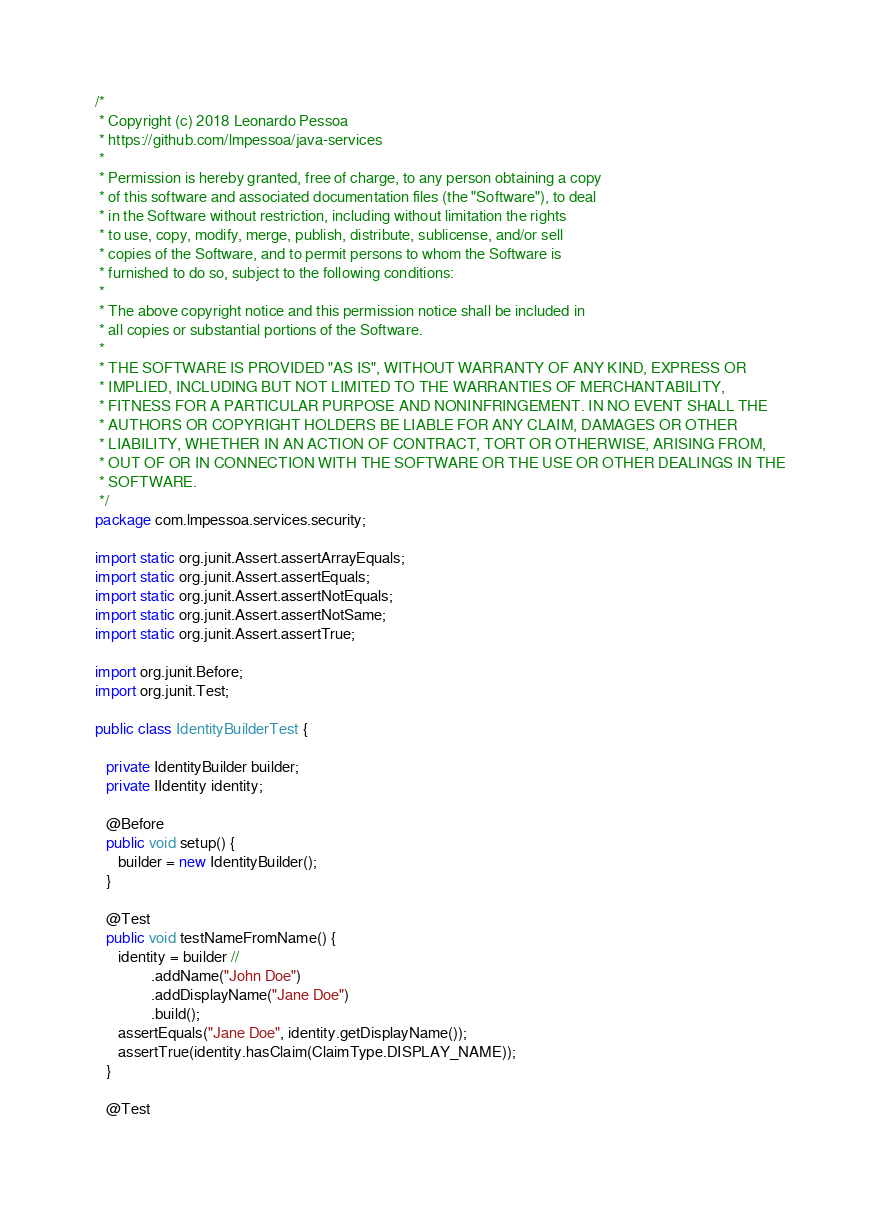<code> <loc_0><loc_0><loc_500><loc_500><_Java_>/*
 * Copyright (c) 2018 Leonardo Pessoa
 * https://github.com/lmpessoa/java-services
 *
 * Permission is hereby granted, free of charge, to any person obtaining a copy
 * of this software and associated documentation files (the "Software"), to deal
 * in the Software without restriction, including without limitation the rights
 * to use, copy, modify, merge, publish, distribute, sublicense, and/or sell
 * copies of the Software, and to permit persons to whom the Software is
 * furnished to do so, subject to the following conditions:
 *
 * The above copyright notice and this permission notice shall be included in
 * all copies or substantial portions of the Software.
 *
 * THE SOFTWARE IS PROVIDED "AS IS", WITHOUT WARRANTY OF ANY KIND, EXPRESS OR
 * IMPLIED, INCLUDING BUT NOT LIMITED TO THE WARRANTIES OF MERCHANTABILITY,
 * FITNESS FOR A PARTICULAR PURPOSE AND NONINFRINGEMENT. IN NO EVENT SHALL THE
 * AUTHORS OR COPYRIGHT HOLDERS BE LIABLE FOR ANY CLAIM, DAMAGES OR OTHER
 * LIABILITY, WHETHER IN AN ACTION OF CONTRACT, TORT OR OTHERWISE, ARISING FROM,
 * OUT OF OR IN CONNECTION WITH THE SOFTWARE OR THE USE OR OTHER DEALINGS IN THE
 * SOFTWARE.
 */
package com.lmpessoa.services.security;

import static org.junit.Assert.assertArrayEquals;
import static org.junit.Assert.assertEquals;
import static org.junit.Assert.assertNotEquals;
import static org.junit.Assert.assertNotSame;
import static org.junit.Assert.assertTrue;

import org.junit.Before;
import org.junit.Test;

public class IdentityBuilderTest {

   private IdentityBuilder builder;
   private IIdentity identity;

   @Before
   public void setup() {
      builder = new IdentityBuilder();
   }

   @Test
   public void testNameFromName() {
      identity = builder //
               .addName("John Doe")
               .addDisplayName("Jane Doe")
               .build();
      assertEquals("Jane Doe", identity.getDisplayName());
      assertTrue(identity.hasClaim(ClaimType.DISPLAY_NAME));
   }

   @Test</code> 